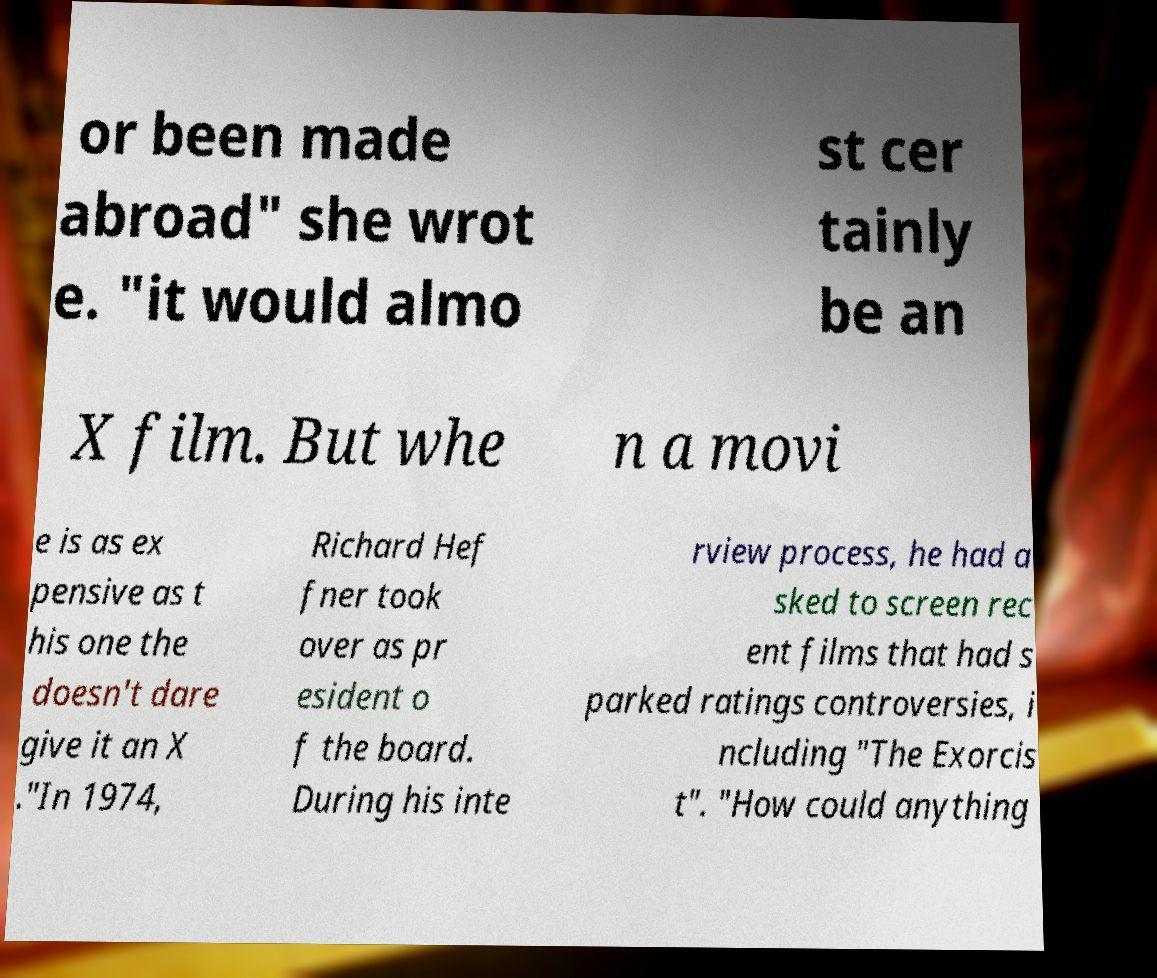I need the written content from this picture converted into text. Can you do that? or been made abroad" she wrot e. "it would almo st cer tainly be an X film. But whe n a movi e is as ex pensive as t his one the doesn't dare give it an X ."In 1974, Richard Hef fner took over as pr esident o f the board. During his inte rview process, he had a sked to screen rec ent films that had s parked ratings controversies, i ncluding "The Exorcis t". "How could anything 